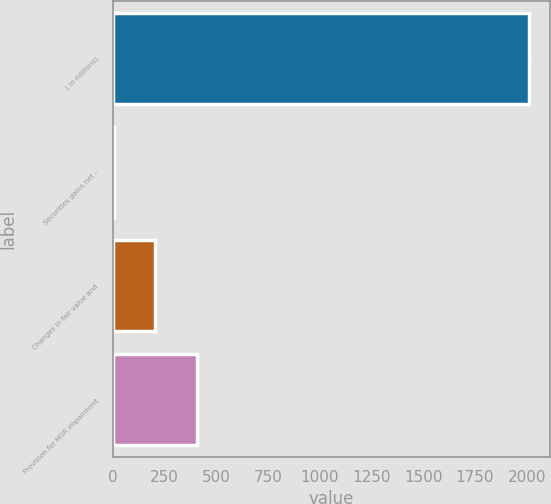Convert chart to OTSL. <chart><loc_0><loc_0><loc_500><loc_500><bar_chart><fcel>( in millions)<fcel>Securities gains net -<fcel>Changes in fair value and<fcel>Provision for MSR impairment<nl><fcel>2012<fcel>3<fcel>203.9<fcel>404.8<nl></chart> 